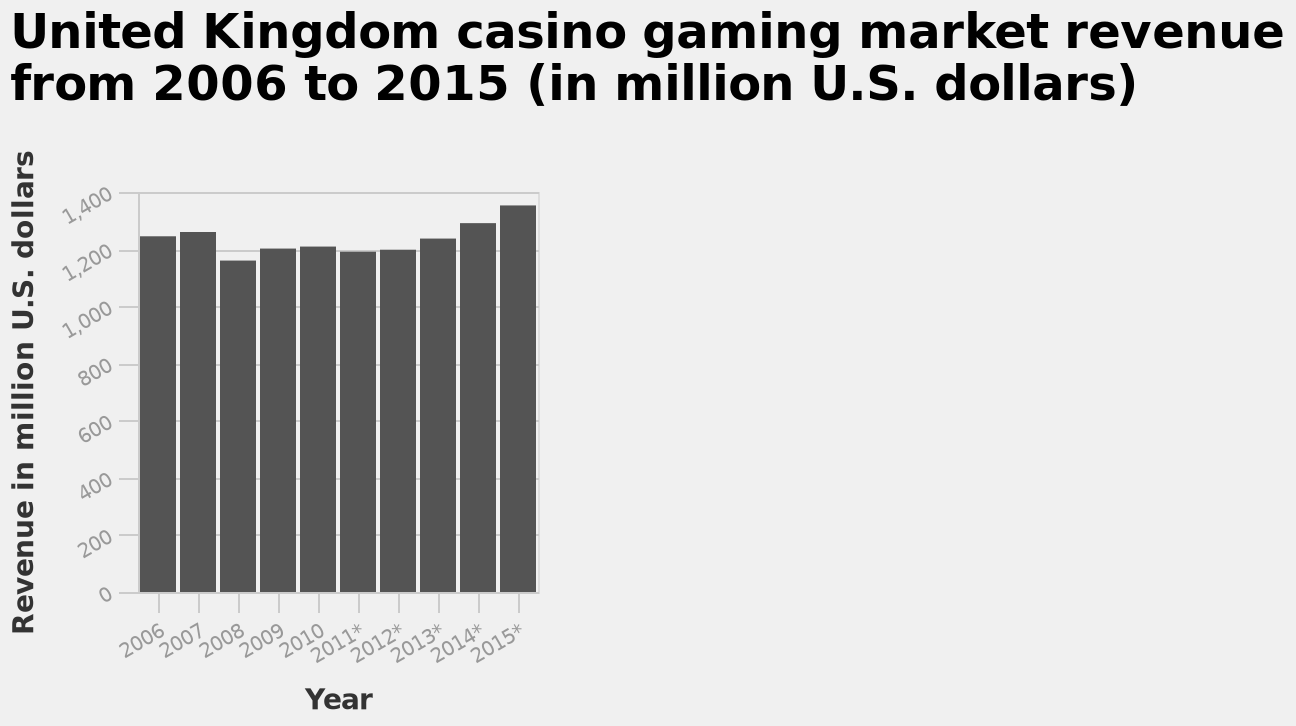<image>
Did the revenue increase from 2013 to 2015? Yes, the revenue was increasing from 2013 to 2015. What does the y-axis measure in the bar plot? The y-axis measures the revenue in million U.S. dollars on a linear scale ranging from 0 to 1,400. What was the approximate revenue from 2009 to 2012?  The revenue from 2009 to 2012 was approximately 1,200 million dollars. Was the drop in revenue significant or minor in 2008? The description states that there was a noticeable drop in revenue in 2008. Offer a thorough analysis of the image. The chart shows there to be a similar trend across the years but a small increase in 2015 shows this is within an upward trend. 